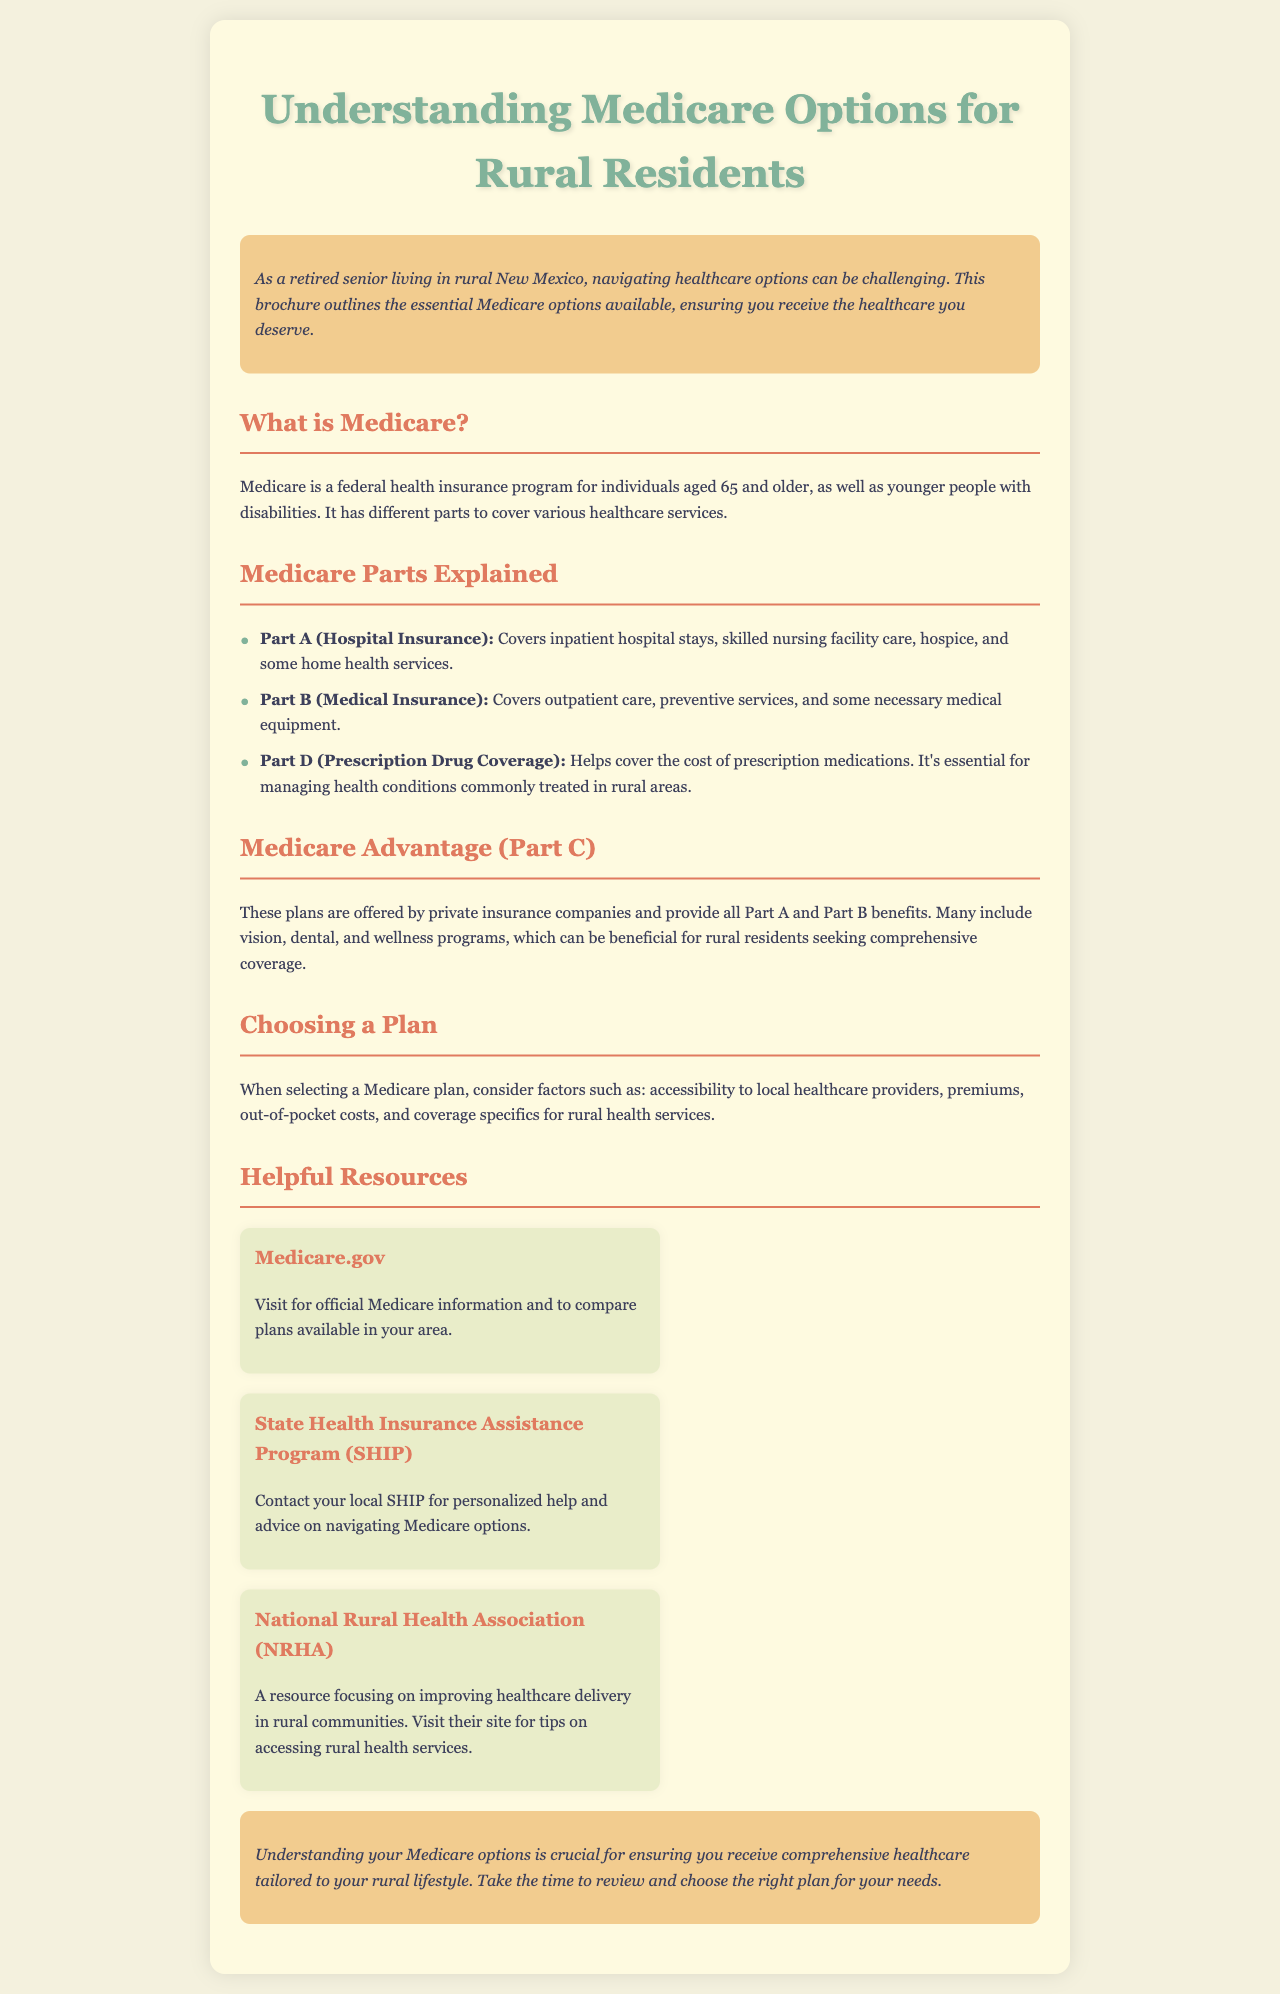What is Medicare? Medicare is defined in the document as a federal health insurance program for individuals age 65 and older and younger people with disabilities.
Answer: federal health insurance program What does Part A cover? The document lists that Part A covers inpatient hospital stays, skilled nursing facility care, hospice, and some home health services.
Answer: inpatient hospital stays, skilled nursing facility care, hospice, and some home health services What is included in Medicare Advantage plans? The brochure states that Medicare Advantage plans often include vision, dental, and wellness programs.
Answer: vision, dental, and wellness programs What should be considered when choosing a Medicare plan? The document mentions accessibility to local healthcare providers, premiums, out-of-pocket costs, and coverage specifics for rural health services as important factors.
Answer: accessibility to local healthcare providers, premiums, out-of-pocket costs, and coverage specifics Which organization provides personalized help regarding Medicare? The brochure refers to the State Health Insurance Assistance Program (SHIP) as the organization for personalized help.
Answer: State Health Insurance Assistance Program (SHIP) What is the purpose of the National Rural Health Association (NRHA)? The document highlights that the NRHA focuses on improving healthcare delivery in rural communities.
Answer: improving healthcare delivery in rural communities How many parts of Medicare are explained in the document? The brochure describes three parts of Medicare: Part A, Part B, and Part D.
Answer: three parts What type of insurance does Part D cover? The document states that Part D helps cover the cost of prescription medications.
Answer: prescription medications What is the color scheme of the brochure? The brochure employs pastel colors such as light beige, soft green, and coral.
Answer: pastel colors like light beige, soft green, and coral 